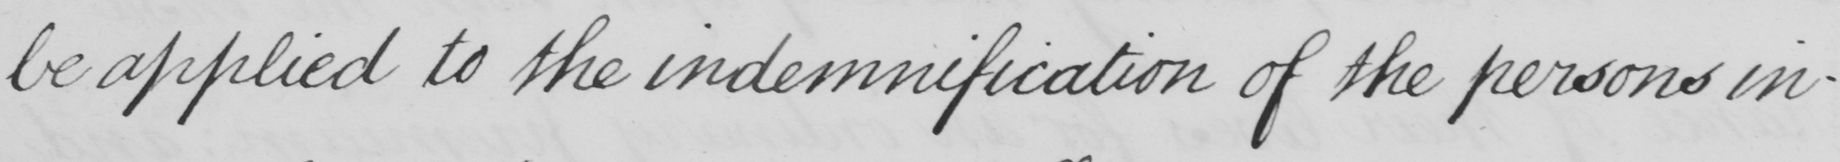What does this handwritten line say? be applied to the indemnification of the persons in- 